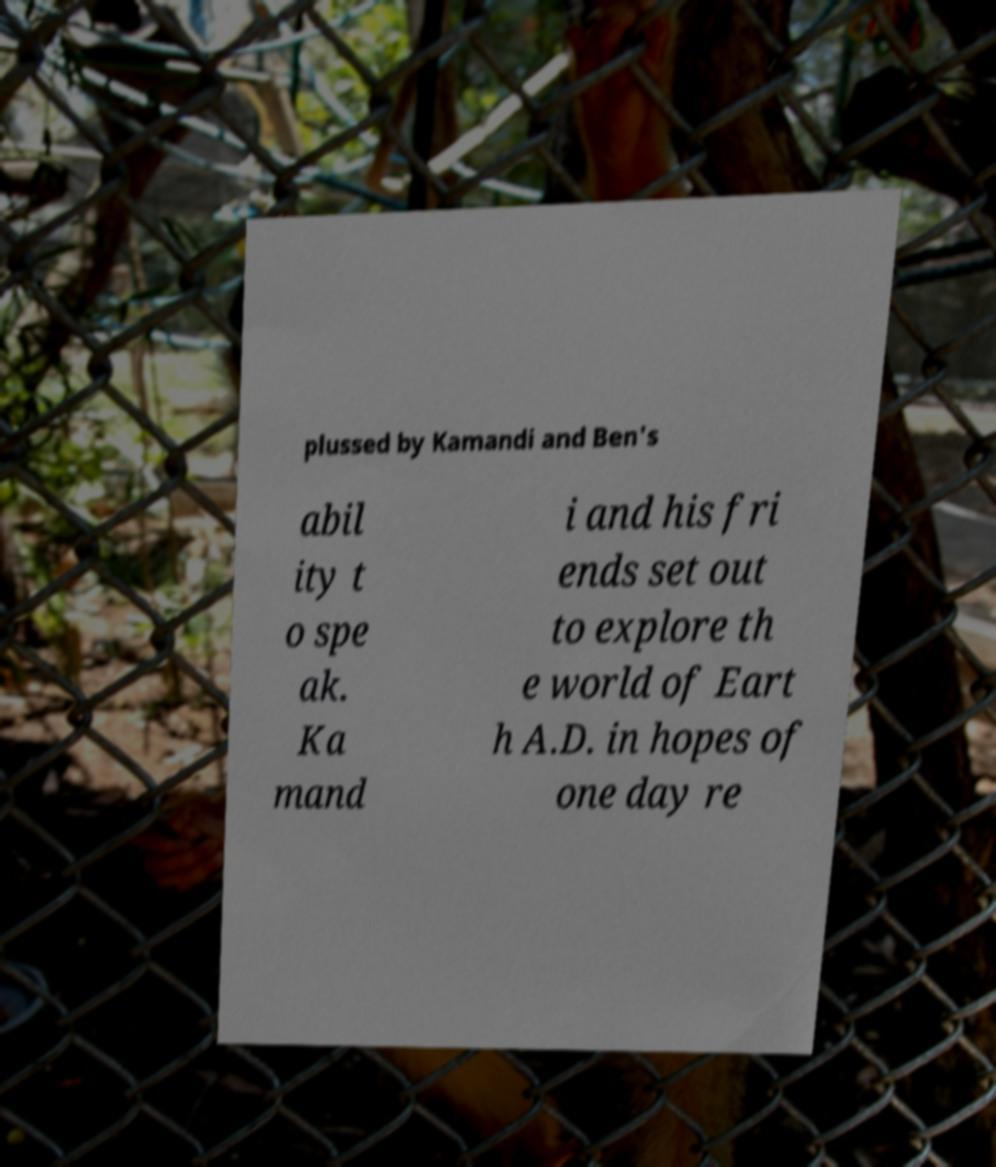Can you read and provide the text displayed in the image?This photo seems to have some interesting text. Can you extract and type it out for me? plussed by Kamandi and Ben's abil ity t o spe ak. Ka mand i and his fri ends set out to explore th e world of Eart h A.D. in hopes of one day re 